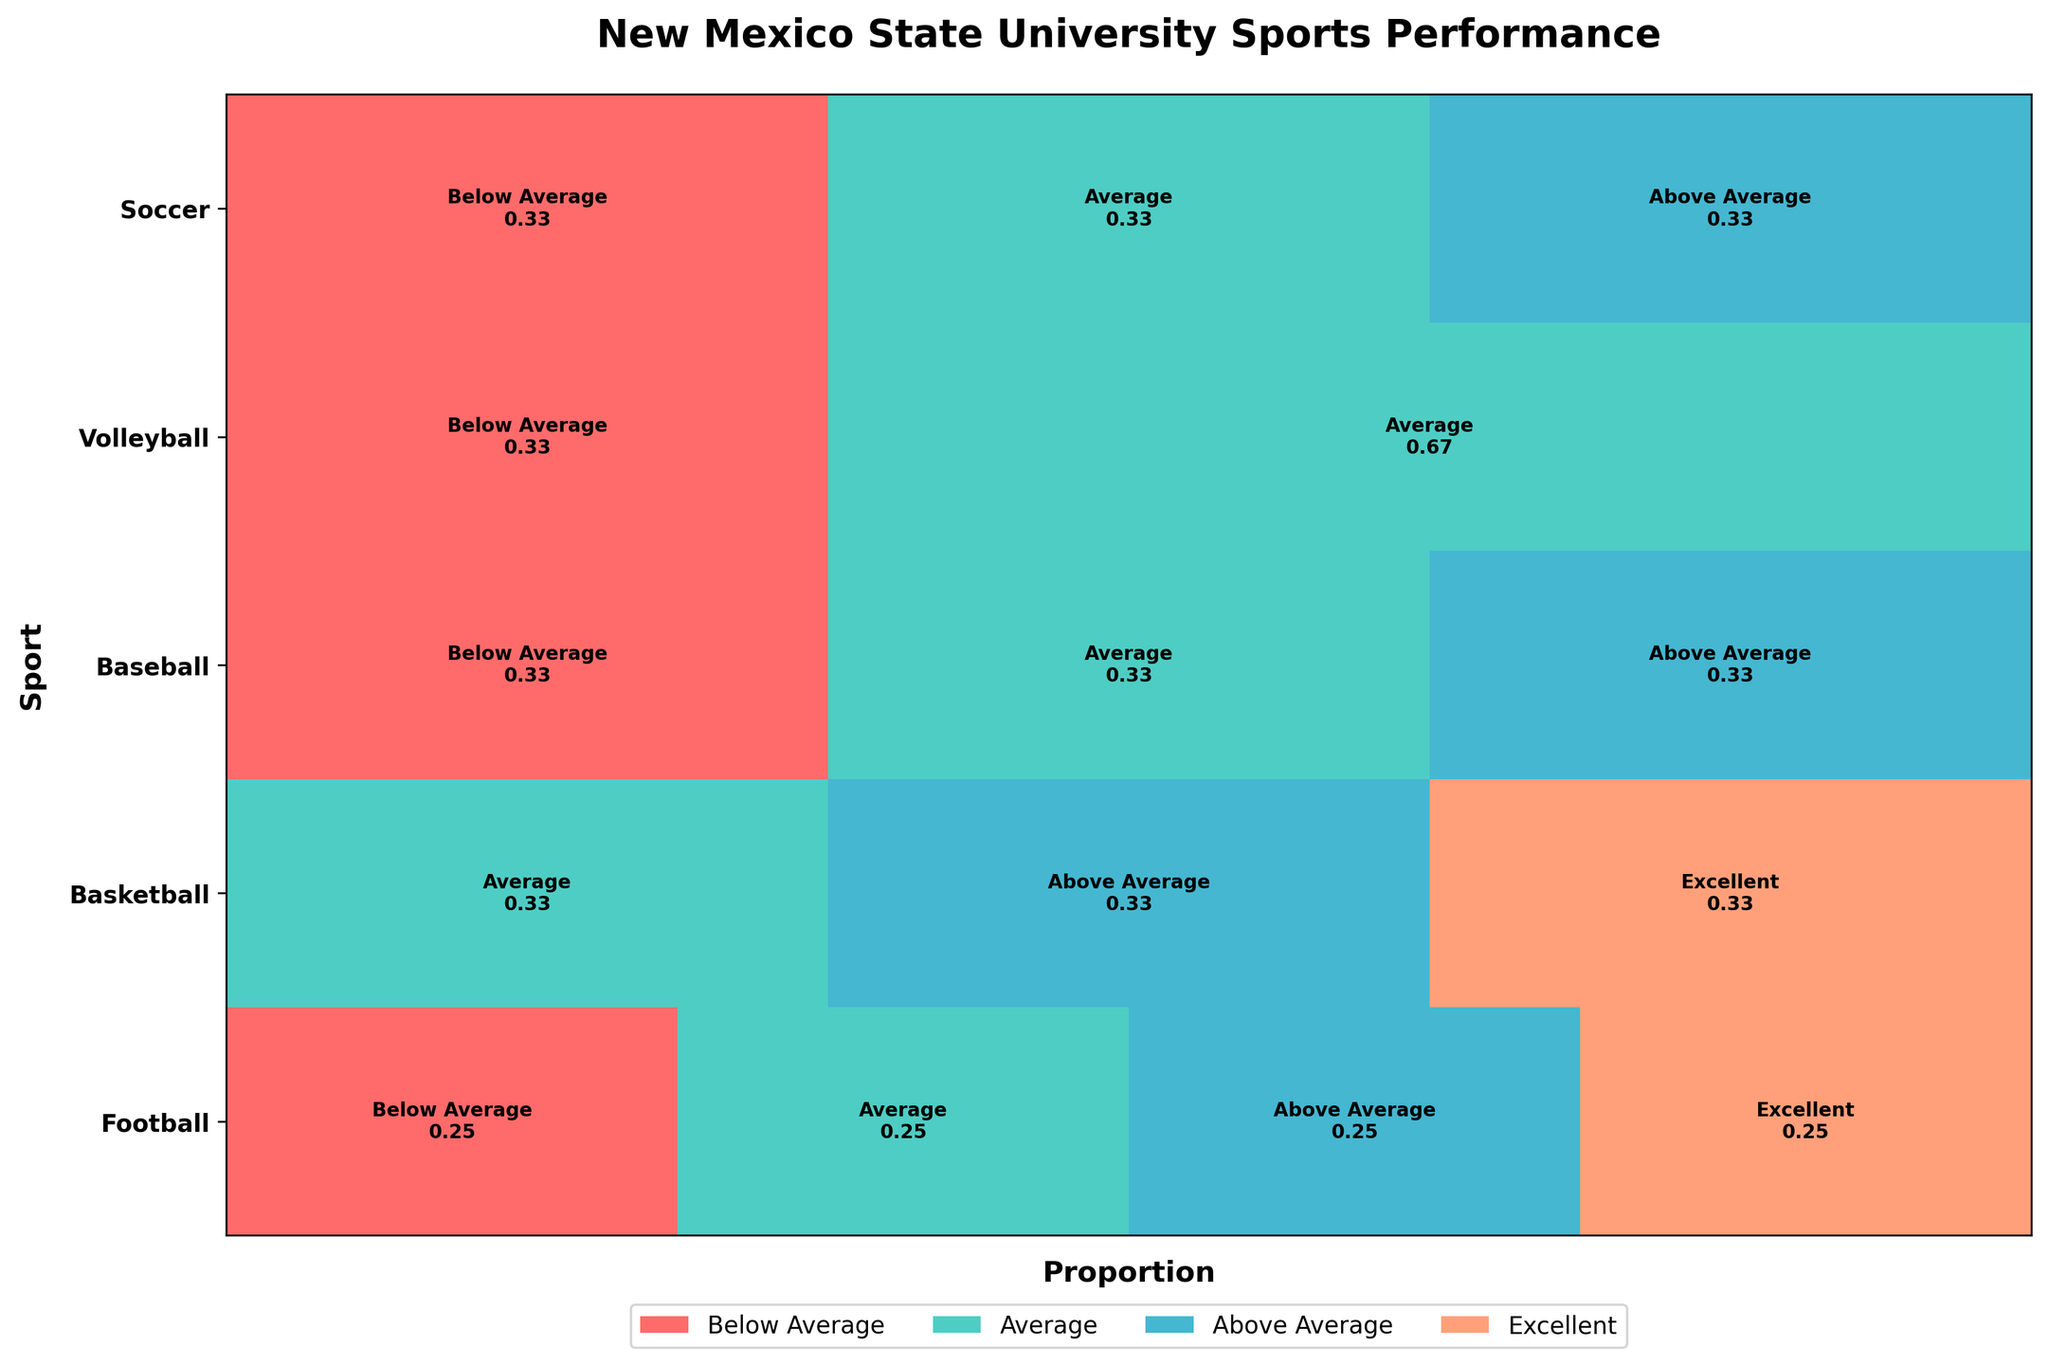What's the title of the plot? The title is located at the top of the plot, and it provides an overview of what the plot is about.
Answer: "New Mexico State University Sports Performance" How many different sports are shown in the plot? By looking at the y-axis labels, we can count the unique sports listed.
Answer: 5 Which sport has the highest proportion of 'Excellent' performance? We can determine this by comparing the width of the 'Excellent' rectangles for each sport. The sport with the widest 'Excellent' section has the highest proportion.
Answer: Football For Volleyball, compare the proportion of 'Average' performance to 'Below Average' performance. The widths of the rectangles for 'Average' and 'Below Average' are compared. For 'Average', the rectangle is wider than 'Below Average'.
Answer: 'Average' has a higher proportion than 'Below Average' What's the proportion of 'Above Average' performance in Basketball? Look at the 'Above Average' section for Basketball and note the width proportion indicated.
Answer: 0.33 Which sport has the lowest proportion of 'Average' performance? Compare the widths of the 'Average' sections for each sport. The sport with the narrowest 'Average' section has the lowest proportion.
Answer: Football What is the overall trend in performance across all sports? Look at the color-coded rectangles for all sports to identify common performance trends, such as the predominance of colors representing higher or lower performances.
Answer: Generally varied, some sports tend more towards average or above average How does the performance of Soccer in 2021 compare to its performance in 2022? Check the widths of the 'Below Average', 'Average', and 'Above Average' sections for Soccer in both years. Note the changes.
Answer: 2021 had 'Average', while 2022 moved to 'Below Average' Which sport has the most consistent performance across the assessed seasons? Consistency implies little variation in performance. Compare the width proportions for each performance type across seasons for each sport to identify the one with minimal changes.
Answer: Basketball What's the proportion of 'Below Average' performance across all sports combined? Sum up the widths of all 'Below Average' sections and average them based on the total number of observations.
Answer: 0.25 